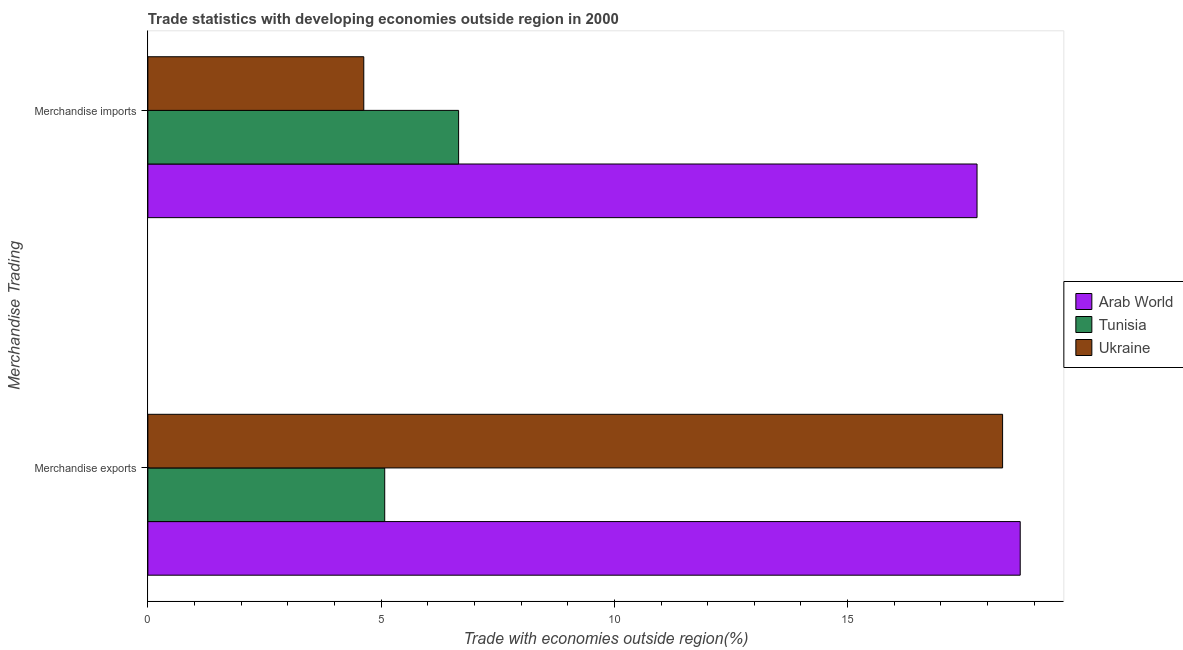How many different coloured bars are there?
Provide a short and direct response. 3. How many groups of bars are there?
Ensure brevity in your answer.  2. Are the number of bars per tick equal to the number of legend labels?
Give a very brief answer. Yes. Are the number of bars on each tick of the Y-axis equal?
Ensure brevity in your answer.  Yes. How many bars are there on the 2nd tick from the top?
Provide a short and direct response. 3. How many bars are there on the 2nd tick from the bottom?
Your response must be concise. 3. What is the label of the 1st group of bars from the top?
Provide a short and direct response. Merchandise imports. What is the merchandise imports in Tunisia?
Offer a very short reply. 6.66. Across all countries, what is the maximum merchandise exports?
Offer a very short reply. 18.7. Across all countries, what is the minimum merchandise imports?
Make the answer very short. 4.63. In which country was the merchandise imports maximum?
Your answer should be very brief. Arab World. In which country was the merchandise imports minimum?
Provide a succinct answer. Ukraine. What is the total merchandise imports in the graph?
Keep it short and to the point. 29.06. What is the difference between the merchandise imports in Ukraine and that in Tunisia?
Your answer should be compact. -2.03. What is the difference between the merchandise exports in Arab World and the merchandise imports in Tunisia?
Provide a succinct answer. 12.04. What is the average merchandise exports per country?
Offer a very short reply. 14.03. What is the difference between the merchandise exports and merchandise imports in Arab World?
Your answer should be compact. 0.93. In how many countries, is the merchandise imports greater than 2 %?
Your answer should be compact. 3. What is the ratio of the merchandise imports in Arab World to that in Ukraine?
Give a very brief answer. 3.84. Is the merchandise exports in Ukraine less than that in Arab World?
Provide a short and direct response. Yes. What does the 3rd bar from the top in Merchandise imports represents?
Keep it short and to the point. Arab World. What does the 2nd bar from the bottom in Merchandise imports represents?
Keep it short and to the point. Tunisia. Are all the bars in the graph horizontal?
Your response must be concise. Yes. How many countries are there in the graph?
Make the answer very short. 3. What is the difference between two consecutive major ticks on the X-axis?
Offer a very short reply. 5. Does the graph contain grids?
Make the answer very short. No. How many legend labels are there?
Provide a short and direct response. 3. How are the legend labels stacked?
Ensure brevity in your answer.  Vertical. What is the title of the graph?
Offer a terse response. Trade statistics with developing economies outside region in 2000. What is the label or title of the X-axis?
Your answer should be very brief. Trade with economies outside region(%). What is the label or title of the Y-axis?
Give a very brief answer. Merchandise Trading. What is the Trade with economies outside region(%) of Arab World in Merchandise exports?
Ensure brevity in your answer.  18.7. What is the Trade with economies outside region(%) of Tunisia in Merchandise exports?
Provide a short and direct response. 5.08. What is the Trade with economies outside region(%) in Ukraine in Merchandise exports?
Give a very brief answer. 18.32. What is the Trade with economies outside region(%) in Arab World in Merchandise imports?
Provide a succinct answer. 17.77. What is the Trade with economies outside region(%) in Tunisia in Merchandise imports?
Ensure brevity in your answer.  6.66. What is the Trade with economies outside region(%) of Ukraine in Merchandise imports?
Keep it short and to the point. 4.63. Across all Merchandise Trading, what is the maximum Trade with economies outside region(%) in Arab World?
Ensure brevity in your answer.  18.7. Across all Merchandise Trading, what is the maximum Trade with economies outside region(%) in Tunisia?
Offer a terse response. 6.66. Across all Merchandise Trading, what is the maximum Trade with economies outside region(%) in Ukraine?
Your answer should be very brief. 18.32. Across all Merchandise Trading, what is the minimum Trade with economies outside region(%) in Arab World?
Ensure brevity in your answer.  17.77. Across all Merchandise Trading, what is the minimum Trade with economies outside region(%) of Tunisia?
Your response must be concise. 5.08. Across all Merchandise Trading, what is the minimum Trade with economies outside region(%) in Ukraine?
Offer a terse response. 4.63. What is the total Trade with economies outside region(%) in Arab World in the graph?
Your response must be concise. 36.48. What is the total Trade with economies outside region(%) in Tunisia in the graph?
Provide a succinct answer. 11.74. What is the total Trade with economies outside region(%) in Ukraine in the graph?
Make the answer very short. 22.95. What is the difference between the Trade with economies outside region(%) in Arab World in Merchandise exports and that in Merchandise imports?
Make the answer very short. 0.93. What is the difference between the Trade with economies outside region(%) of Tunisia in Merchandise exports and that in Merchandise imports?
Ensure brevity in your answer.  -1.58. What is the difference between the Trade with economies outside region(%) in Ukraine in Merchandise exports and that in Merchandise imports?
Your response must be concise. 13.69. What is the difference between the Trade with economies outside region(%) of Arab World in Merchandise exports and the Trade with economies outside region(%) of Tunisia in Merchandise imports?
Provide a short and direct response. 12.04. What is the difference between the Trade with economies outside region(%) of Arab World in Merchandise exports and the Trade with economies outside region(%) of Ukraine in Merchandise imports?
Give a very brief answer. 14.07. What is the difference between the Trade with economies outside region(%) in Tunisia in Merchandise exports and the Trade with economies outside region(%) in Ukraine in Merchandise imports?
Offer a very short reply. 0.45. What is the average Trade with economies outside region(%) of Arab World per Merchandise Trading?
Your response must be concise. 18.24. What is the average Trade with economies outside region(%) of Tunisia per Merchandise Trading?
Make the answer very short. 5.87. What is the average Trade with economies outside region(%) of Ukraine per Merchandise Trading?
Your response must be concise. 11.48. What is the difference between the Trade with economies outside region(%) of Arab World and Trade with economies outside region(%) of Tunisia in Merchandise exports?
Your response must be concise. 13.62. What is the difference between the Trade with economies outside region(%) in Arab World and Trade with economies outside region(%) in Ukraine in Merchandise exports?
Your answer should be very brief. 0.38. What is the difference between the Trade with economies outside region(%) in Tunisia and Trade with economies outside region(%) in Ukraine in Merchandise exports?
Make the answer very short. -13.25. What is the difference between the Trade with economies outside region(%) in Arab World and Trade with economies outside region(%) in Tunisia in Merchandise imports?
Provide a succinct answer. 11.11. What is the difference between the Trade with economies outside region(%) of Arab World and Trade with economies outside region(%) of Ukraine in Merchandise imports?
Your answer should be very brief. 13.15. What is the difference between the Trade with economies outside region(%) of Tunisia and Trade with economies outside region(%) of Ukraine in Merchandise imports?
Provide a succinct answer. 2.03. What is the ratio of the Trade with economies outside region(%) in Arab World in Merchandise exports to that in Merchandise imports?
Your response must be concise. 1.05. What is the ratio of the Trade with economies outside region(%) in Tunisia in Merchandise exports to that in Merchandise imports?
Provide a short and direct response. 0.76. What is the ratio of the Trade with economies outside region(%) in Ukraine in Merchandise exports to that in Merchandise imports?
Offer a terse response. 3.96. What is the difference between the highest and the second highest Trade with economies outside region(%) of Arab World?
Make the answer very short. 0.93. What is the difference between the highest and the second highest Trade with economies outside region(%) in Tunisia?
Your answer should be very brief. 1.58. What is the difference between the highest and the second highest Trade with economies outside region(%) of Ukraine?
Offer a terse response. 13.69. What is the difference between the highest and the lowest Trade with economies outside region(%) of Arab World?
Your answer should be compact. 0.93. What is the difference between the highest and the lowest Trade with economies outside region(%) in Tunisia?
Keep it short and to the point. 1.58. What is the difference between the highest and the lowest Trade with economies outside region(%) in Ukraine?
Provide a succinct answer. 13.69. 